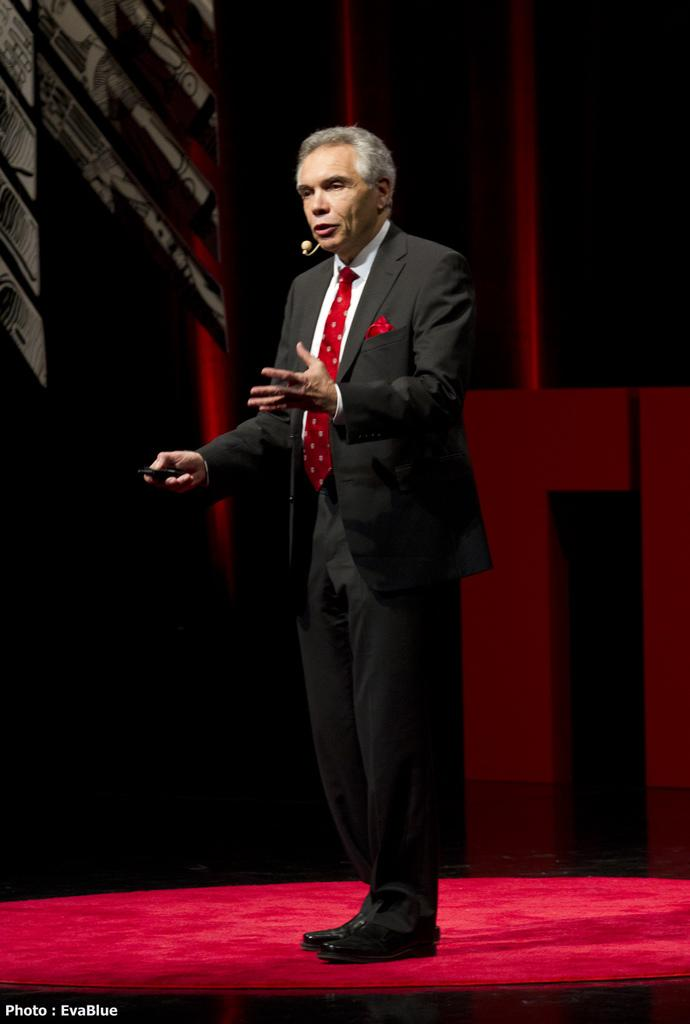What is present in the image? There is a man in the image. Can you describe the man's clothing? The man is wearing a black color jacket. How would you describe the lighting in the image? The image is a little dark. What type of vein can be seen on the man's hand in the image? There is no visible vein on the man's hand in the image. What color are the man's boots in the image? There are no boots visible in the image. 